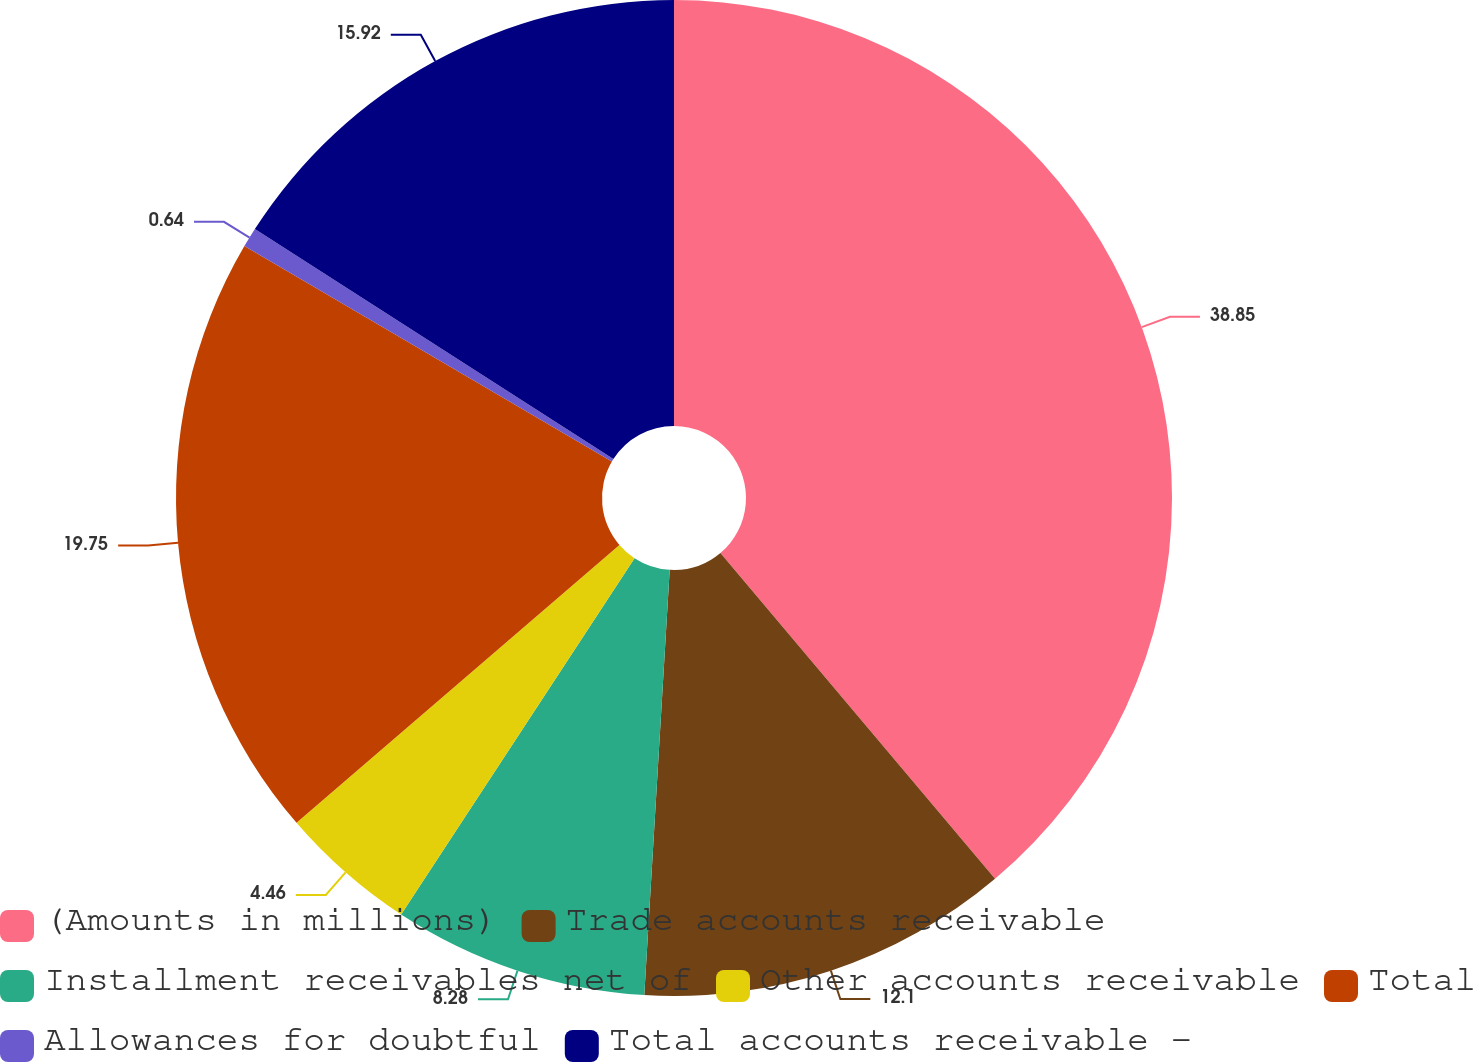Convert chart to OTSL. <chart><loc_0><loc_0><loc_500><loc_500><pie_chart><fcel>(Amounts in millions)<fcel>Trade accounts receivable<fcel>Installment receivables net of<fcel>Other accounts receivable<fcel>Total<fcel>Allowances for doubtful<fcel>Total accounts receivable -<nl><fcel>38.85%<fcel>12.1%<fcel>8.28%<fcel>4.46%<fcel>19.75%<fcel>0.64%<fcel>15.92%<nl></chart> 